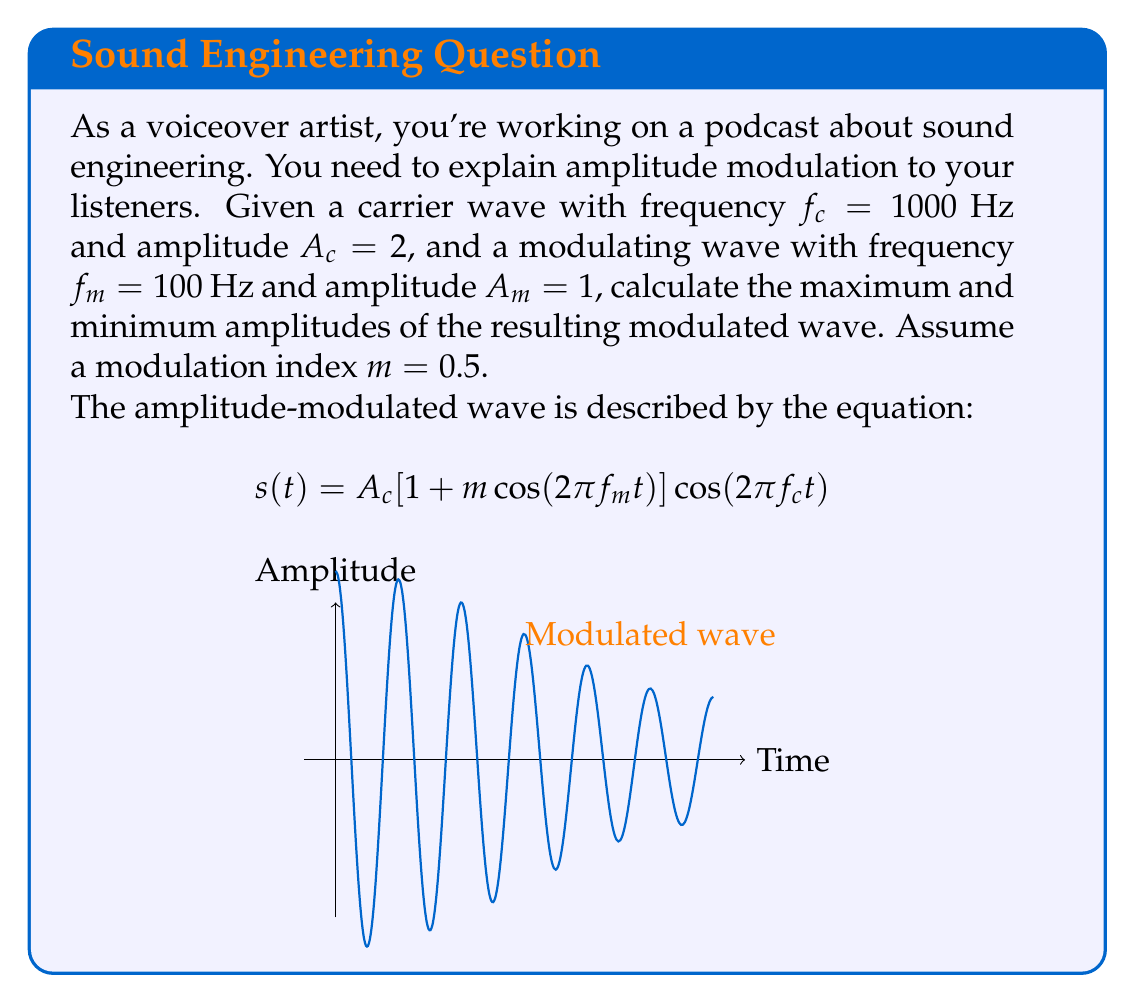Could you help me with this problem? Let's approach this step-by-step:

1) The amplitude of the modulated wave varies between $A_c(1-m)$ and $A_c(1+m)$.

2) We're given:
   $A_c = 2$ (carrier amplitude)
   $m = 0.5$ (modulation index)

3) To find the maximum amplitude:
   $A_{max} = A_c(1+m)$
   $A_{max} = 2(1+0.5)$
   $A_{max} = 2(1.5) = 3$

4) To find the minimum amplitude:
   $A_{min} = A_c(1-m)$
   $A_{min} = 2(1-0.5)$
   $A_{min} = 2(0.5) = 1$

5) Therefore, the amplitude of the modulated wave varies between 1 and 3.

Note: The frequencies $f_c$ and $f_m$ don't affect the amplitude calculation, but they determine the shape of the wave over time.
Answer: $A_{max} = 3$, $A_{min} = 1$ 